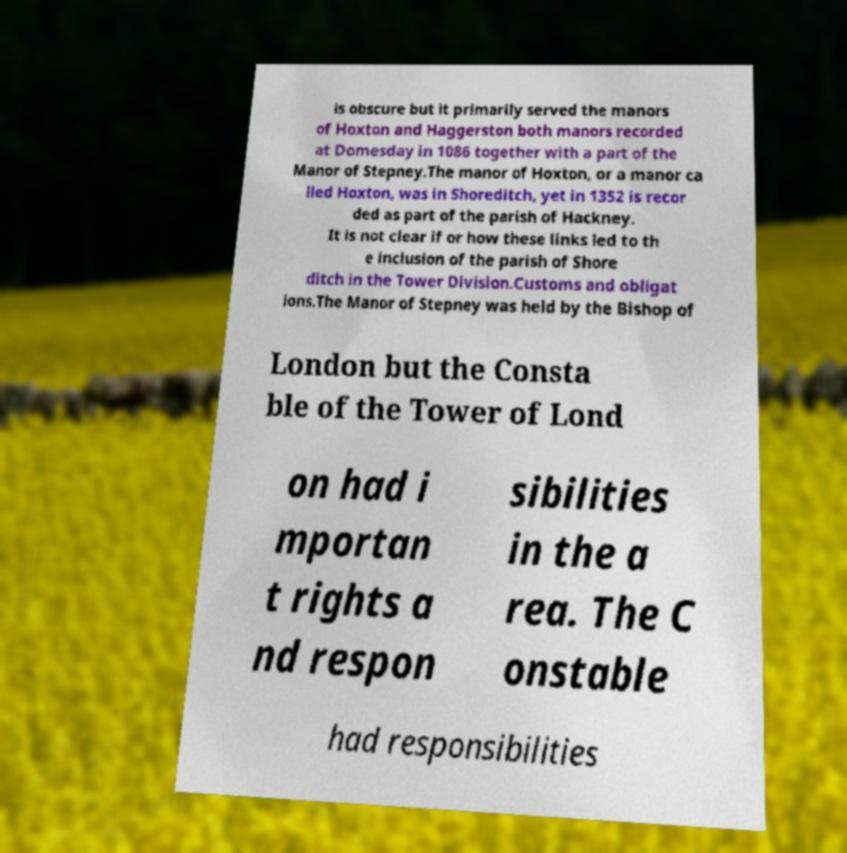What messages or text are displayed in this image? I need them in a readable, typed format. is obscure but it primarily served the manors of Hoxton and Haggerston both manors recorded at Domesday in 1086 together with a part of the Manor of Stepney.The manor of Hoxton, or a manor ca lled Hoxton, was in Shoreditch, yet in 1352 is recor ded as part of the parish of Hackney. It is not clear if or how these links led to th e inclusion of the parish of Shore ditch in the Tower Division.Customs and obligat ions.The Manor of Stepney was held by the Bishop of London but the Consta ble of the Tower of Lond on had i mportan t rights a nd respon sibilities in the a rea. The C onstable had responsibilities 